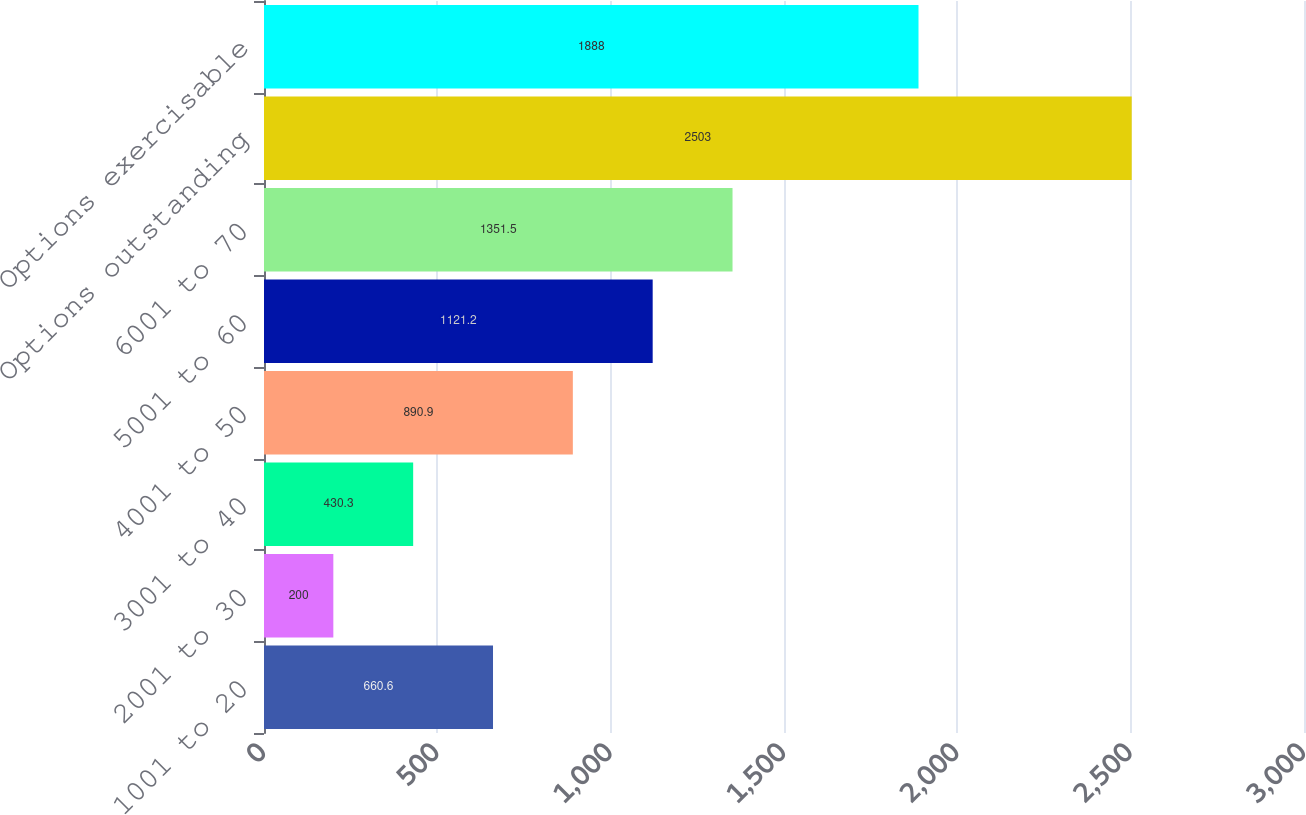Convert chart. <chart><loc_0><loc_0><loc_500><loc_500><bar_chart><fcel>1001 to 20<fcel>2001 to 30<fcel>3001 to 40<fcel>4001 to 50<fcel>5001 to 60<fcel>6001 to 70<fcel>Options outstanding<fcel>Options exercisable<nl><fcel>660.6<fcel>200<fcel>430.3<fcel>890.9<fcel>1121.2<fcel>1351.5<fcel>2503<fcel>1888<nl></chart> 